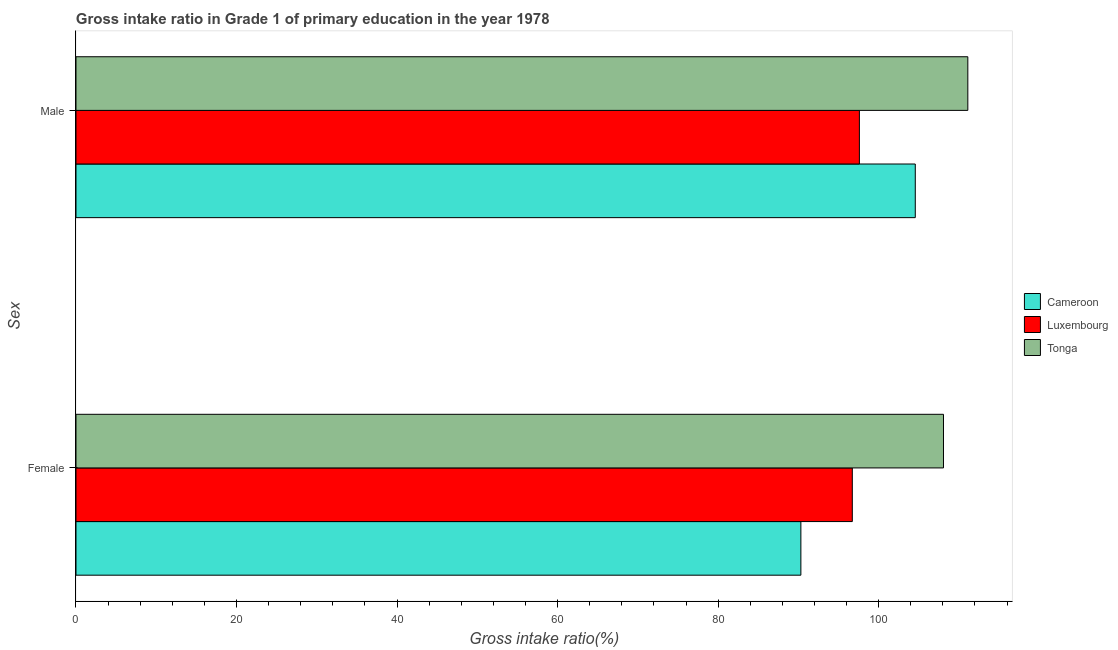How many different coloured bars are there?
Keep it short and to the point. 3. How many groups of bars are there?
Make the answer very short. 2. Are the number of bars per tick equal to the number of legend labels?
Give a very brief answer. Yes. How many bars are there on the 2nd tick from the top?
Provide a succinct answer. 3. What is the gross intake ratio(male) in Tonga?
Keep it short and to the point. 111.11. Across all countries, what is the maximum gross intake ratio(female)?
Give a very brief answer. 108.08. Across all countries, what is the minimum gross intake ratio(male)?
Offer a very short reply. 97.6. In which country was the gross intake ratio(male) maximum?
Offer a very short reply. Tonga. In which country was the gross intake ratio(male) minimum?
Your answer should be very brief. Luxembourg. What is the total gross intake ratio(female) in the graph?
Ensure brevity in your answer.  295.11. What is the difference between the gross intake ratio(male) in Tonga and that in Cameroon?
Keep it short and to the point. 6.55. What is the difference between the gross intake ratio(female) in Luxembourg and the gross intake ratio(male) in Tonga?
Keep it short and to the point. -14.39. What is the average gross intake ratio(male) per country?
Your answer should be compact. 104.43. What is the difference between the gross intake ratio(female) and gross intake ratio(male) in Cameroon?
Provide a succinct answer. -14.25. What is the ratio of the gross intake ratio(male) in Cameroon to that in Tonga?
Your answer should be compact. 0.94. Is the gross intake ratio(male) in Luxembourg less than that in Cameroon?
Your answer should be compact. Yes. What does the 1st bar from the top in Male represents?
Your answer should be very brief. Tonga. What does the 1st bar from the bottom in Male represents?
Your answer should be compact. Cameroon. How many bars are there?
Offer a very short reply. 6. Are all the bars in the graph horizontal?
Offer a very short reply. Yes. What is the difference between two consecutive major ticks on the X-axis?
Your response must be concise. 20. Does the graph contain grids?
Your response must be concise. No. Where does the legend appear in the graph?
Your answer should be compact. Center right. What is the title of the graph?
Your answer should be compact. Gross intake ratio in Grade 1 of primary education in the year 1978. What is the label or title of the X-axis?
Ensure brevity in your answer.  Gross intake ratio(%). What is the label or title of the Y-axis?
Your answer should be compact. Sex. What is the Gross intake ratio(%) of Cameroon in Female?
Keep it short and to the point. 90.31. What is the Gross intake ratio(%) in Luxembourg in Female?
Your answer should be compact. 96.72. What is the Gross intake ratio(%) in Tonga in Female?
Your answer should be very brief. 108.08. What is the Gross intake ratio(%) of Cameroon in Male?
Offer a very short reply. 104.57. What is the Gross intake ratio(%) in Luxembourg in Male?
Make the answer very short. 97.6. What is the Gross intake ratio(%) of Tonga in Male?
Give a very brief answer. 111.11. Across all Sex, what is the maximum Gross intake ratio(%) in Cameroon?
Offer a terse response. 104.57. Across all Sex, what is the maximum Gross intake ratio(%) in Luxembourg?
Offer a terse response. 97.6. Across all Sex, what is the maximum Gross intake ratio(%) of Tonga?
Ensure brevity in your answer.  111.11. Across all Sex, what is the minimum Gross intake ratio(%) in Cameroon?
Your response must be concise. 90.31. Across all Sex, what is the minimum Gross intake ratio(%) of Luxembourg?
Provide a short and direct response. 96.72. Across all Sex, what is the minimum Gross intake ratio(%) in Tonga?
Provide a succinct answer. 108.08. What is the total Gross intake ratio(%) of Cameroon in the graph?
Your answer should be compact. 194.88. What is the total Gross intake ratio(%) of Luxembourg in the graph?
Your answer should be very brief. 194.32. What is the total Gross intake ratio(%) in Tonga in the graph?
Offer a terse response. 219.19. What is the difference between the Gross intake ratio(%) of Cameroon in Female and that in Male?
Your response must be concise. -14.25. What is the difference between the Gross intake ratio(%) of Luxembourg in Female and that in Male?
Keep it short and to the point. -0.88. What is the difference between the Gross intake ratio(%) of Tonga in Female and that in Male?
Your answer should be very brief. -3.03. What is the difference between the Gross intake ratio(%) of Cameroon in Female and the Gross intake ratio(%) of Luxembourg in Male?
Your answer should be compact. -7.29. What is the difference between the Gross intake ratio(%) of Cameroon in Female and the Gross intake ratio(%) of Tonga in Male?
Make the answer very short. -20.8. What is the difference between the Gross intake ratio(%) of Luxembourg in Female and the Gross intake ratio(%) of Tonga in Male?
Offer a very short reply. -14.39. What is the average Gross intake ratio(%) in Cameroon per Sex?
Your answer should be very brief. 97.44. What is the average Gross intake ratio(%) of Luxembourg per Sex?
Give a very brief answer. 97.16. What is the average Gross intake ratio(%) in Tonga per Sex?
Provide a short and direct response. 109.6. What is the difference between the Gross intake ratio(%) in Cameroon and Gross intake ratio(%) in Luxembourg in Female?
Your response must be concise. -6.41. What is the difference between the Gross intake ratio(%) of Cameroon and Gross intake ratio(%) of Tonga in Female?
Keep it short and to the point. -17.77. What is the difference between the Gross intake ratio(%) in Luxembourg and Gross intake ratio(%) in Tonga in Female?
Your answer should be very brief. -11.36. What is the difference between the Gross intake ratio(%) of Cameroon and Gross intake ratio(%) of Luxembourg in Male?
Make the answer very short. 6.96. What is the difference between the Gross intake ratio(%) in Cameroon and Gross intake ratio(%) in Tonga in Male?
Offer a very short reply. -6.55. What is the difference between the Gross intake ratio(%) in Luxembourg and Gross intake ratio(%) in Tonga in Male?
Give a very brief answer. -13.51. What is the ratio of the Gross intake ratio(%) of Cameroon in Female to that in Male?
Ensure brevity in your answer.  0.86. What is the ratio of the Gross intake ratio(%) of Tonga in Female to that in Male?
Make the answer very short. 0.97. What is the difference between the highest and the second highest Gross intake ratio(%) in Cameroon?
Keep it short and to the point. 14.25. What is the difference between the highest and the second highest Gross intake ratio(%) in Luxembourg?
Ensure brevity in your answer.  0.88. What is the difference between the highest and the second highest Gross intake ratio(%) of Tonga?
Your answer should be compact. 3.03. What is the difference between the highest and the lowest Gross intake ratio(%) of Cameroon?
Offer a very short reply. 14.25. What is the difference between the highest and the lowest Gross intake ratio(%) of Luxembourg?
Ensure brevity in your answer.  0.88. What is the difference between the highest and the lowest Gross intake ratio(%) in Tonga?
Provide a short and direct response. 3.03. 